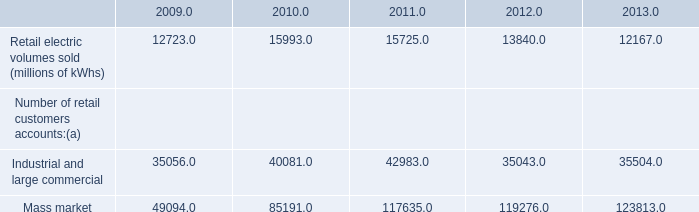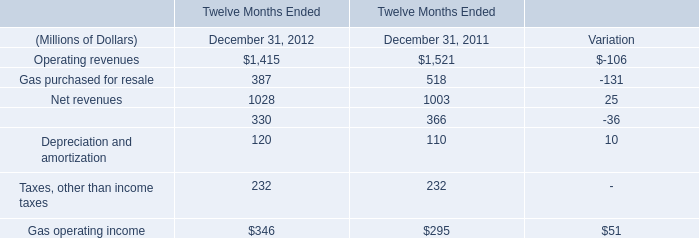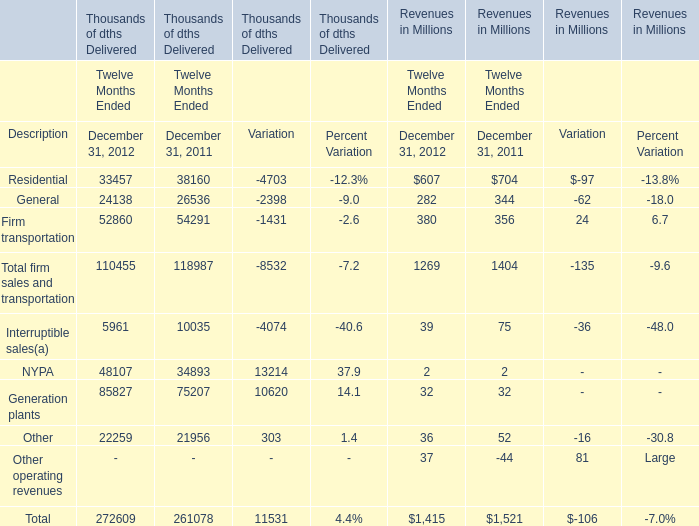What's the sum of the Operating revenues and the Net revenues in 2011 Ended December 31? (in million) 
Computations: (1521 + 1003)
Answer: 2524.0. 